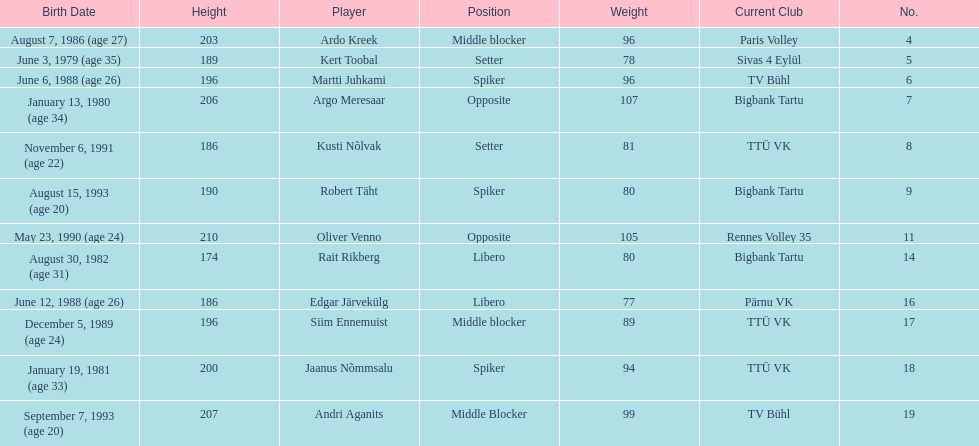Kert toobal is the oldest who is the next oldest player listed? Argo Meresaar. 